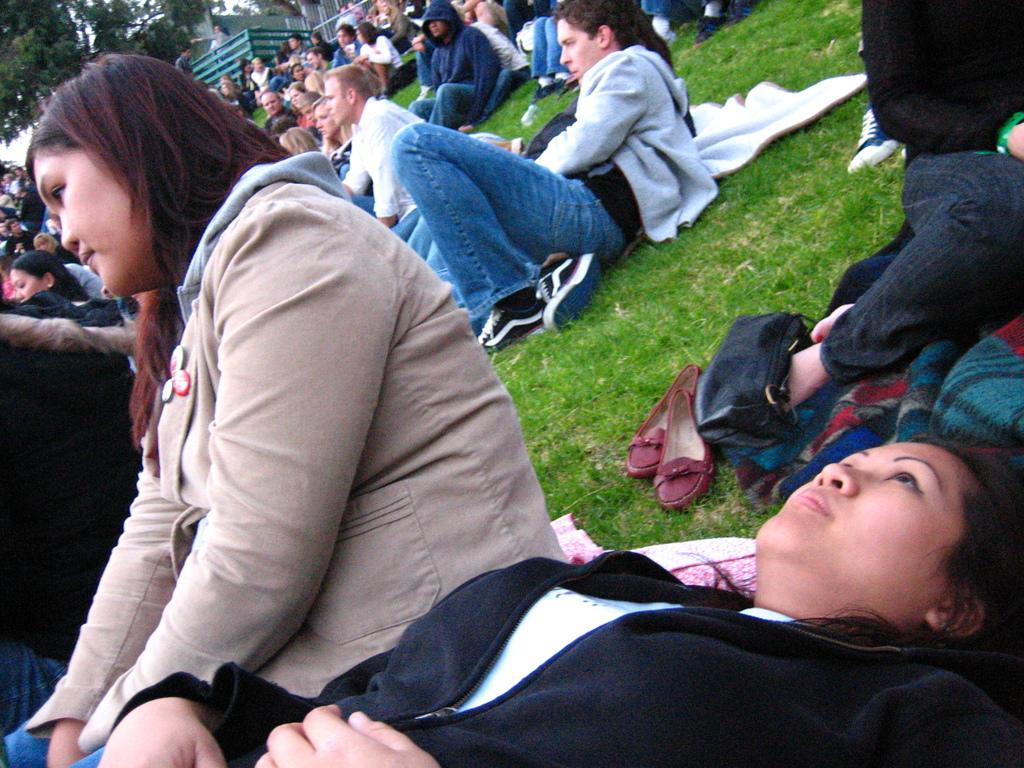What is the girl in the image doing? The girl is sleeping in the image. Who is the girl looking at? The girl is looking at someone in the image. What are the people in the image doing? The people in the image are sitting on the ground. What type of surface is the ground made of? The ground is full of grass. What type of apparatus is being used by the girl in the image? There is no apparatus present in the image; the girl is simply sleeping. What need does the girl have that is not being met in the image? There is no indication of any unmet needs in the image; the girl is sleeping peacefully. 